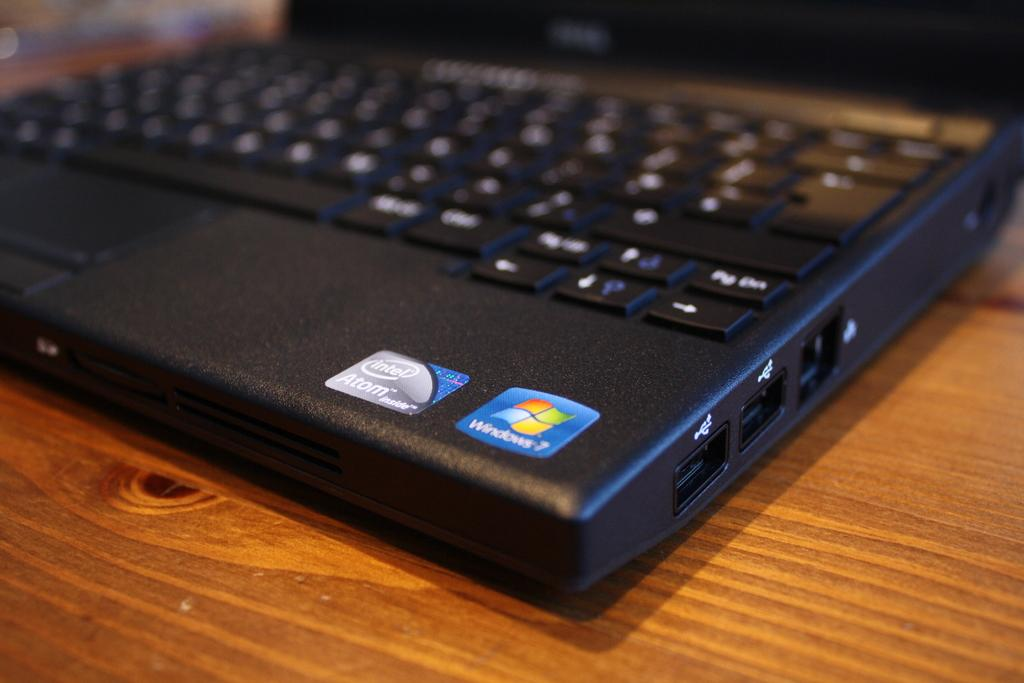<image>
Give a short and clear explanation of the subsequent image. Windows 7 sticker on a black laptop on a table. 